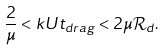Convert formula to latex. <formula><loc_0><loc_0><loc_500><loc_500>\frac { 2 } { \mu } < k U t _ { d r a g } < 2 \mu \mathcal { R } _ { d } .</formula> 